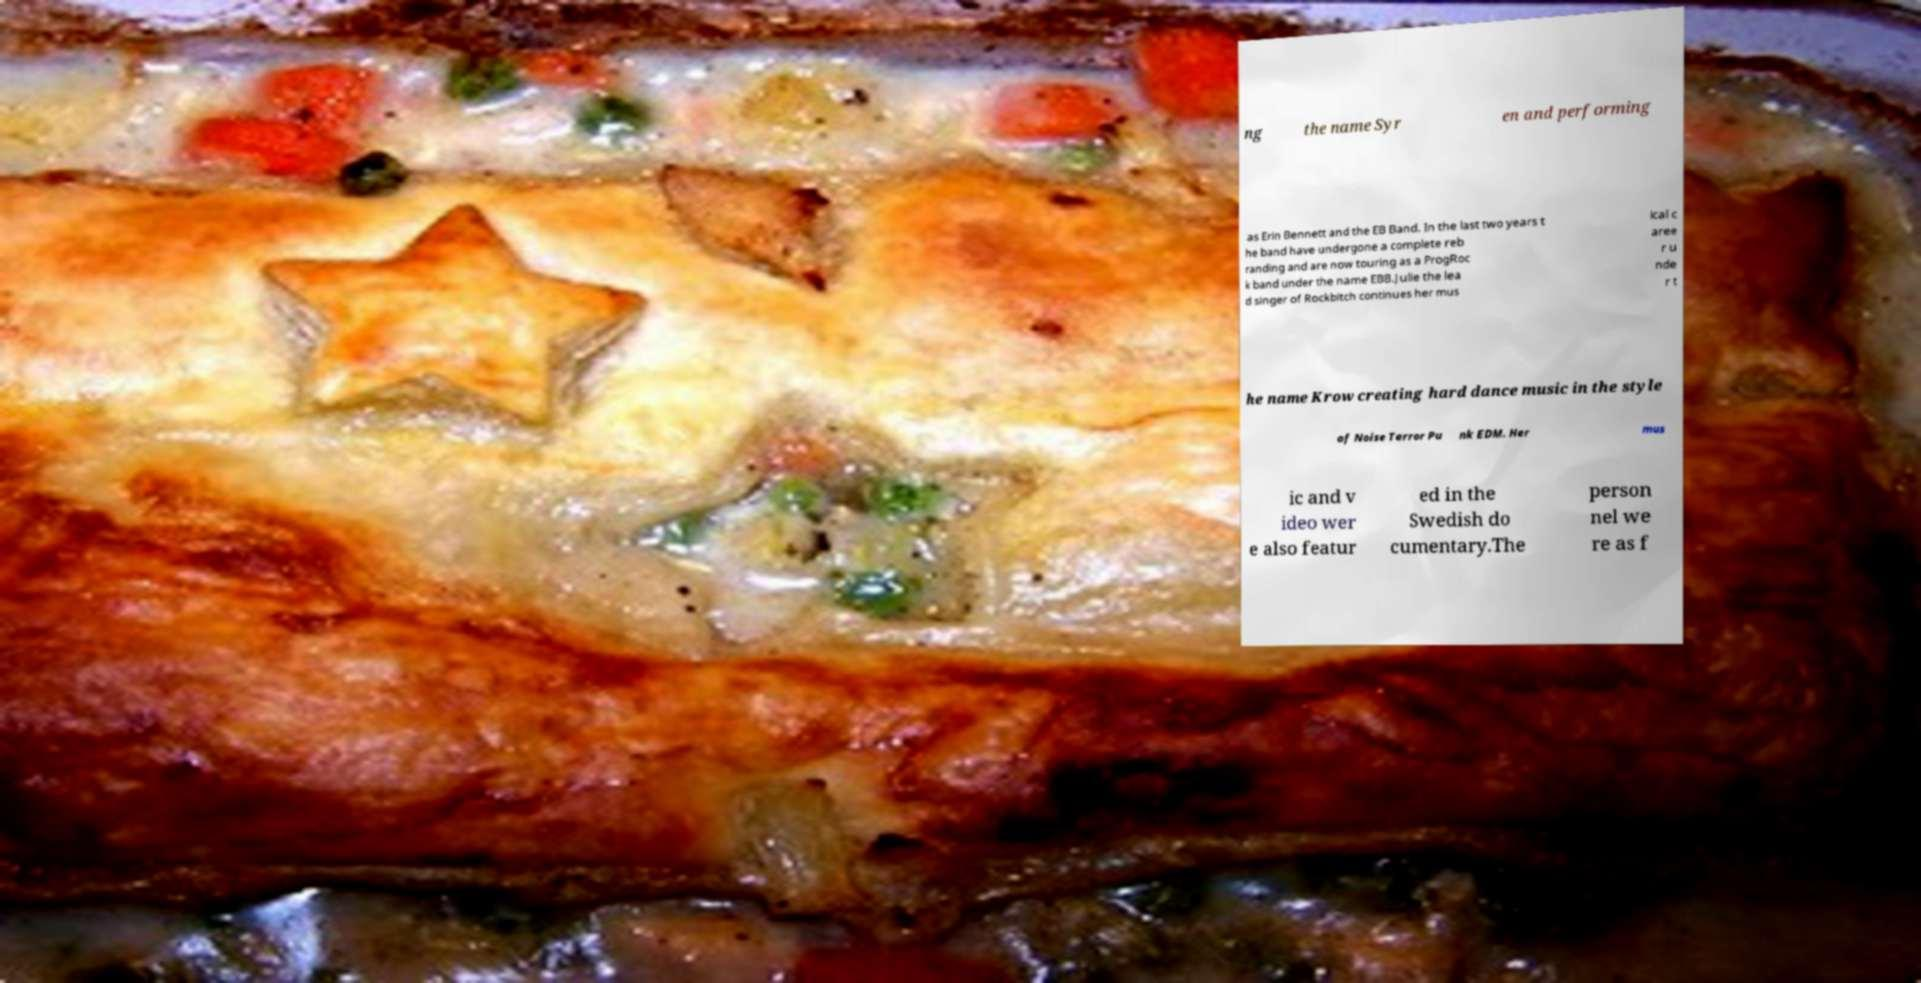Could you assist in decoding the text presented in this image and type it out clearly? ng the name Syr en and performing as Erin Bennett and the EB Band. In the last two years t he band have undergone a complete reb randing and are now touring as a ProgRoc k band under the name EBB.Julie the lea d singer of Rockbitch continues her mus ical c aree r u nde r t he name Krow creating hard dance music in the style of Noise Terror Pu nk EDM. Her mus ic and v ideo wer e also featur ed in the Swedish do cumentary.The person nel we re as f 